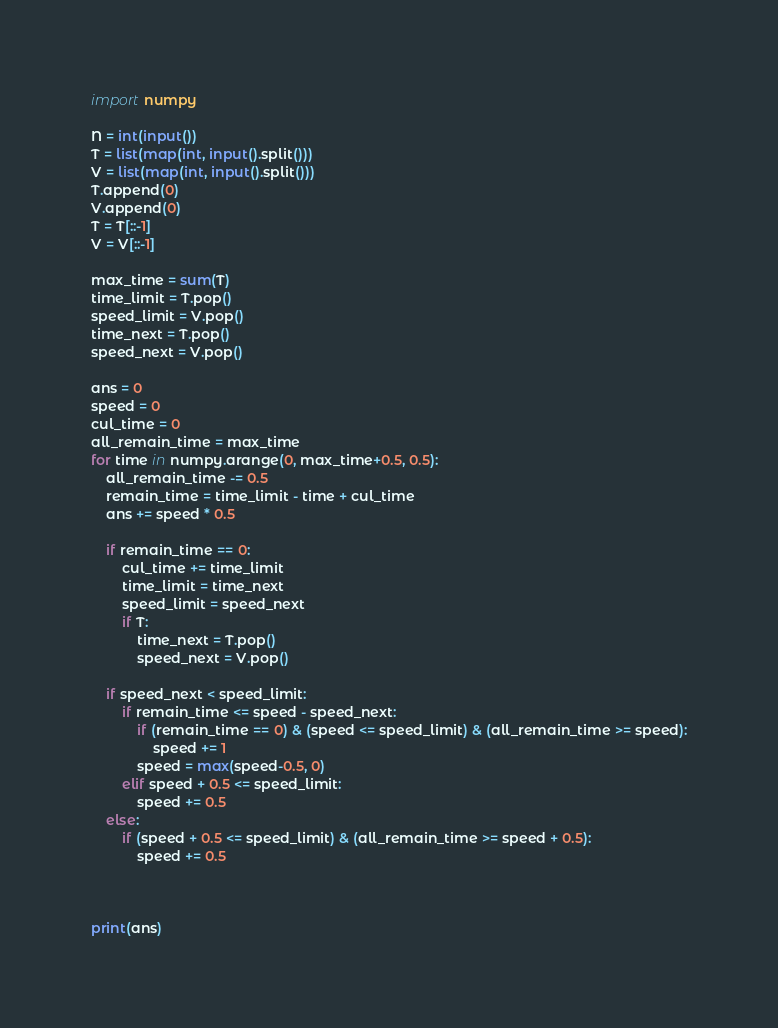Convert code to text. <code><loc_0><loc_0><loc_500><loc_500><_Python_>import numpy

N = int(input())
T = list(map(int, input().split()))
V = list(map(int, input().split()))
T.append(0)
V.append(0)
T = T[::-1]
V = V[::-1]

max_time = sum(T)
time_limit = T.pop()
speed_limit = V.pop()
time_next = T.pop()
speed_next = V.pop()

ans = 0
speed = 0
cul_time = 0
all_remain_time = max_time
for time in numpy.arange(0, max_time+0.5, 0.5):
    all_remain_time -= 0.5
    remain_time = time_limit - time + cul_time
    ans += speed * 0.5

    if remain_time == 0:
        cul_time += time_limit
        time_limit = time_next
        speed_limit = speed_next
        if T:
            time_next = T.pop()
            speed_next = V.pop()

    if speed_next < speed_limit:
        if remain_time <= speed - speed_next:
            if (remain_time == 0) & (speed <= speed_limit) & (all_remain_time >= speed):
                speed += 1
            speed = max(speed-0.5, 0)
        elif speed + 0.5 <= speed_limit:
            speed += 0.5
    else:
        if (speed + 0.5 <= speed_limit) & (all_remain_time >= speed + 0.5):
            speed += 0.5



print(ans)</code> 